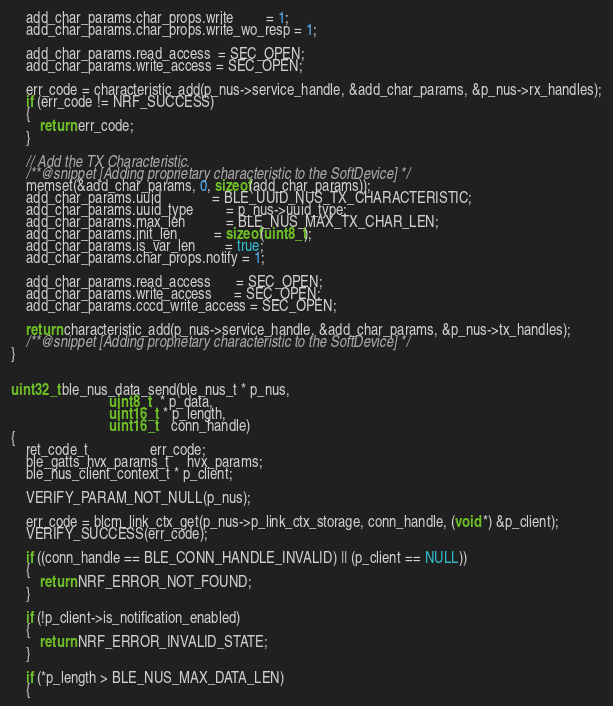Convert code to text. <code><loc_0><loc_0><loc_500><loc_500><_C_>    add_char_params.char_props.write         = 1;
    add_char_params.char_props.write_wo_resp = 1;

    add_char_params.read_access  = SEC_OPEN;
    add_char_params.write_access = SEC_OPEN;

    err_code = characteristic_add(p_nus->service_handle, &add_char_params, &p_nus->rx_handles);
    if (err_code != NRF_SUCCESS)
    {
        return err_code;
    }

    // Add the TX Characteristic.
    /**@snippet [Adding proprietary characteristic to the SoftDevice] */
    memset(&add_char_params, 0, sizeof(add_char_params));
    add_char_params.uuid              = BLE_UUID_NUS_TX_CHARACTERISTIC;
    add_char_params.uuid_type         = p_nus->uuid_type;
    add_char_params.max_len           = BLE_NUS_MAX_TX_CHAR_LEN;
    add_char_params.init_len          = sizeof(uint8_t);
    add_char_params.is_var_len        = true;
    add_char_params.char_props.notify = 1;

    add_char_params.read_access       = SEC_OPEN;
    add_char_params.write_access      = SEC_OPEN;
    add_char_params.cccd_write_access = SEC_OPEN;

    return characteristic_add(p_nus->service_handle, &add_char_params, &p_nus->tx_handles);
    /**@snippet [Adding proprietary characteristic to the SoftDevice] */
}


uint32_t ble_nus_data_send(ble_nus_t * p_nus,
                           uint8_t   * p_data,
                           uint16_t  * p_length,
                           uint16_t    conn_handle)
{
    ret_code_t                 err_code;
    ble_gatts_hvx_params_t     hvx_params;
    ble_nus_client_context_t * p_client;

    VERIFY_PARAM_NOT_NULL(p_nus);

    err_code = blcm_link_ctx_get(p_nus->p_link_ctx_storage, conn_handle, (void *) &p_client);
    VERIFY_SUCCESS(err_code);

    if ((conn_handle == BLE_CONN_HANDLE_INVALID) || (p_client == NULL))
    {
        return NRF_ERROR_NOT_FOUND;
    }

    if (!p_client->is_notification_enabled)
    {
        return NRF_ERROR_INVALID_STATE;
    }

    if (*p_length > BLE_NUS_MAX_DATA_LEN)
    {</code> 